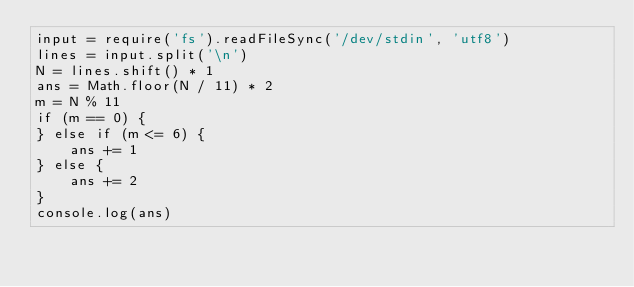Convert code to text. <code><loc_0><loc_0><loc_500><loc_500><_JavaScript_>input = require('fs').readFileSync('/dev/stdin', 'utf8')
lines = input.split('\n')
N = lines.shift() * 1
ans = Math.floor(N / 11) * 2
m = N % 11
if (m == 0) {
} else if (m <= 6) {
    ans += 1
} else {
    ans += 2
} 
console.log(ans)</code> 